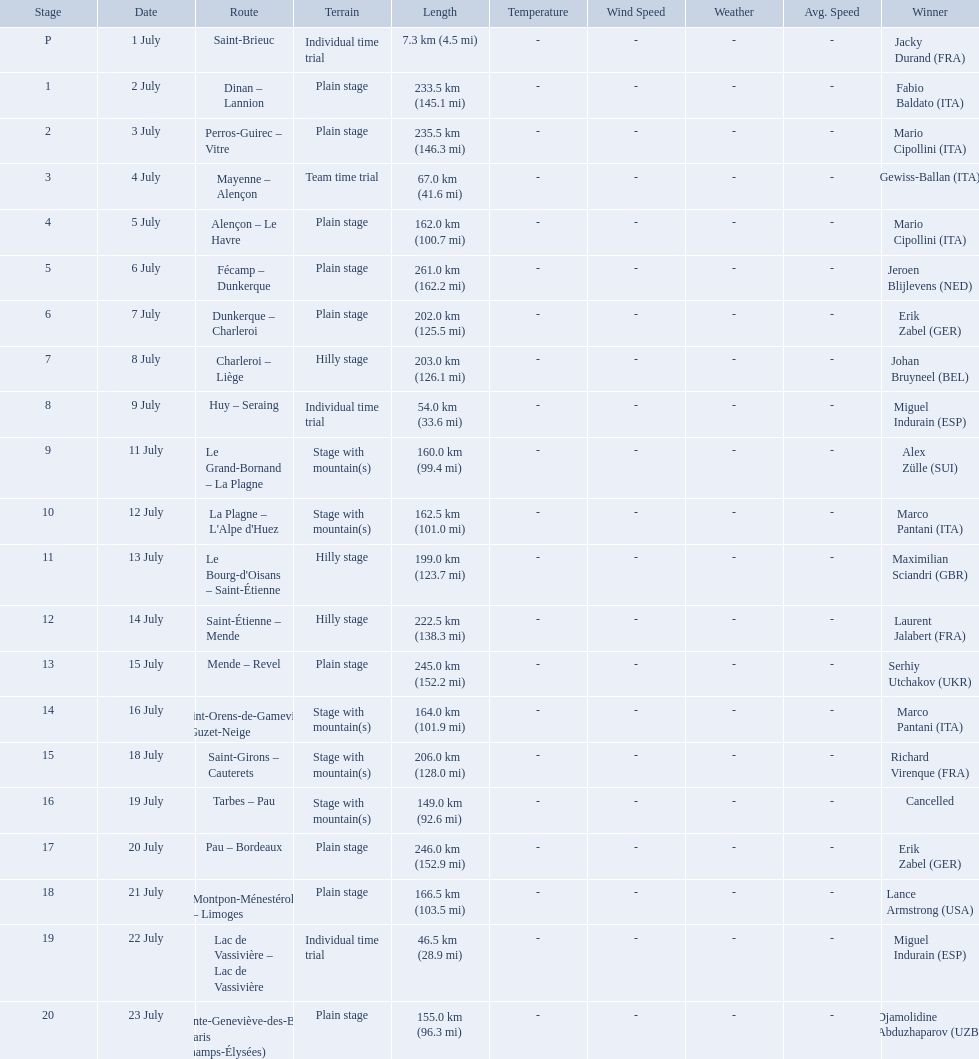What are the dates? 1 July, 2 July, 3 July, 4 July, 5 July, 6 July, 7 July, 8 July, 9 July, 11 July, 12 July, 13 July, 14 July, 15 July, 16 July, 18 July, 19 July, 20 July, 21 July, 22 July, 23 July. What is the length on 8 july? 203.0 km (126.1 mi). 